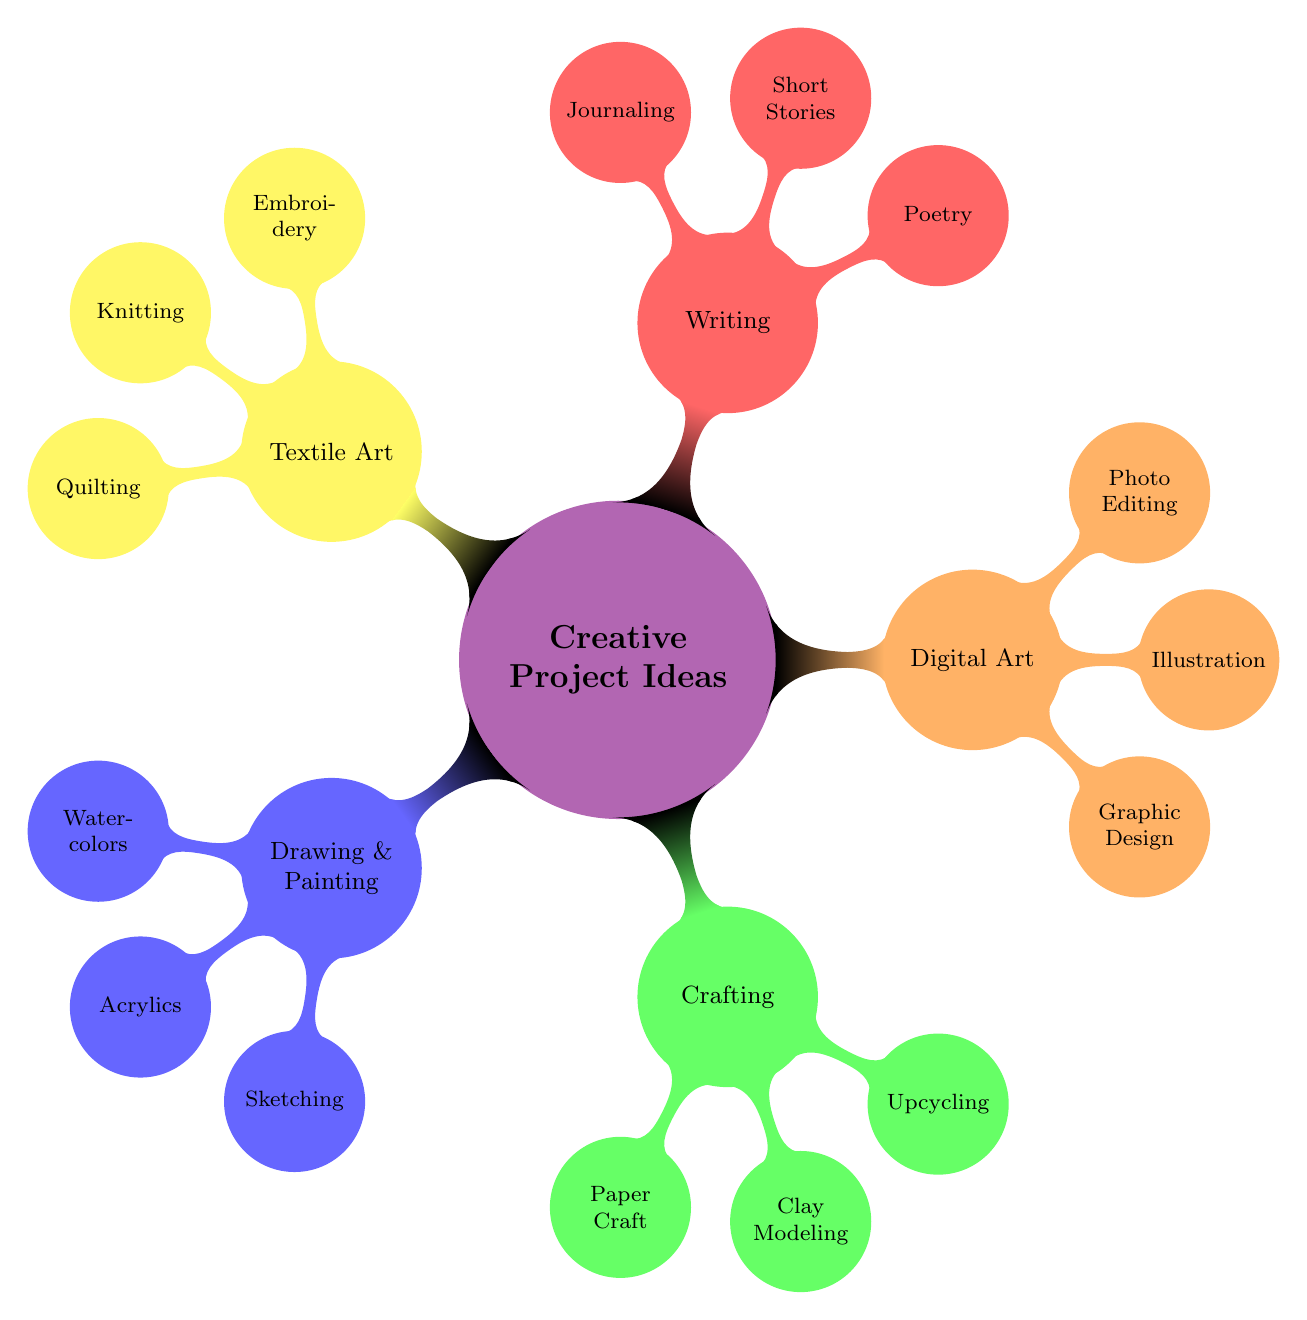What are the main categories of creative project ideas? The central node has five main categories branching out from it: Drawing & Painting, Crafting, Digital Art, Writing, and Textile Art.
Answer: Drawing & Painting, Crafting, Digital Art, Writing, Textile Art How many types of projects are listed under Crafting? Under the Crafting category, there are three different project types: Paper Craft, Clay Modeling, and Upcycling.
Answer: 3 What type of art involves creating social media posts? The project type that involves creating social media posts falls under the Digital Art category, specifically Graphic Design.
Answer: Graphic Design Which project type includes tales inspired by dreams? Short Stories, listed under the Writing category, specifically includes tales inspired by dreams.
Answer: Short Stories What is one common theme among the project ideas in Textile Art? The common theme is the use of fabric, with project types like Embroidery, Knitting, and Quilting all revolving around textile manipulation.
Answer: Fabric How many different techniques are mentioned under Drawing & Painting? There are three techniques mentioned under Drawing & Painting: Watercolors, Acrylics, and Sketching.
Answer: 3 Which art form might be best suited for those who enjoy writing poetry? Poetry is found in the Writing category and is specifically aimed at those who enjoy writing versatile formats like haikus about parenthood.
Answer: Poetry What is an example of a project idea in Upcycling? Upcycling is described with the project idea of transforming old clothes into art pieces, demonstrating innovative reuse.
Answer: Transforming old clothes into art pieces What does the project type "Miniature garden figures" belong to? Miniature garden figures are classified under the Clay Modeling project type within the Crafting category.
Answer: Clay Modeling 